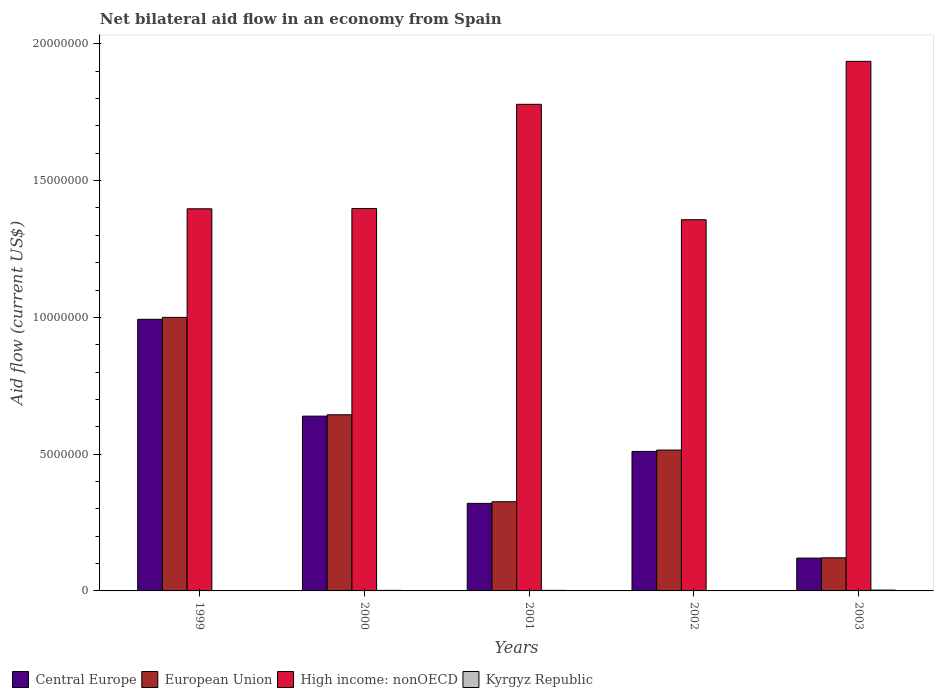Are the number of bars per tick equal to the number of legend labels?
Offer a terse response. Yes. Are the number of bars on each tick of the X-axis equal?
Your answer should be compact. Yes. How many bars are there on the 1st tick from the left?
Ensure brevity in your answer.  4. What is the label of the 5th group of bars from the left?
Your answer should be compact. 2003. In how many cases, is the number of bars for a given year not equal to the number of legend labels?
Give a very brief answer. 0. What is the net bilateral aid flow in Central Europe in 2002?
Ensure brevity in your answer.  5.10e+06. Across all years, what is the minimum net bilateral aid flow in Central Europe?
Ensure brevity in your answer.  1.20e+06. In which year was the net bilateral aid flow in European Union maximum?
Give a very brief answer. 1999. What is the total net bilateral aid flow in European Union in the graph?
Your answer should be compact. 2.61e+07. What is the difference between the net bilateral aid flow in Kyrgyz Republic in 2001 and that in 2003?
Your answer should be compact. -10000. What is the difference between the net bilateral aid flow in Kyrgyz Republic in 2000 and the net bilateral aid flow in High income: nonOECD in 2002?
Ensure brevity in your answer.  -1.36e+07. What is the average net bilateral aid flow in Kyrgyz Republic per year?
Provide a succinct answer. 1.80e+04. In how many years, is the net bilateral aid flow in Kyrgyz Republic greater than 16000000 US$?
Your answer should be compact. 0. Is the difference between the net bilateral aid flow in Central Europe in 2000 and 2001 greater than the difference between the net bilateral aid flow in European Union in 2000 and 2001?
Offer a very short reply. Yes. What is the difference between the highest and the second highest net bilateral aid flow in European Union?
Offer a very short reply. 3.56e+06. What is the difference between the highest and the lowest net bilateral aid flow in High income: nonOECD?
Your response must be concise. 5.79e+06. Is the sum of the net bilateral aid flow in High income: nonOECD in 1999 and 2003 greater than the maximum net bilateral aid flow in Kyrgyz Republic across all years?
Your answer should be very brief. Yes. What does the 3rd bar from the left in 2002 represents?
Give a very brief answer. High income: nonOECD. What does the 1st bar from the right in 2002 represents?
Your answer should be very brief. Kyrgyz Republic. Is it the case that in every year, the sum of the net bilateral aid flow in High income: nonOECD and net bilateral aid flow in European Union is greater than the net bilateral aid flow in Central Europe?
Offer a terse response. Yes. How many bars are there?
Offer a terse response. 20. What is the difference between two consecutive major ticks on the Y-axis?
Your answer should be very brief. 5.00e+06. Does the graph contain any zero values?
Your response must be concise. No. How are the legend labels stacked?
Offer a very short reply. Horizontal. What is the title of the graph?
Offer a terse response. Net bilateral aid flow in an economy from Spain. What is the label or title of the X-axis?
Provide a succinct answer. Years. What is the Aid flow (current US$) in Central Europe in 1999?
Your answer should be compact. 9.93e+06. What is the Aid flow (current US$) of European Union in 1999?
Make the answer very short. 1.00e+07. What is the Aid flow (current US$) in High income: nonOECD in 1999?
Your answer should be compact. 1.40e+07. What is the Aid flow (current US$) of Central Europe in 2000?
Provide a short and direct response. 6.39e+06. What is the Aid flow (current US$) in European Union in 2000?
Keep it short and to the point. 6.44e+06. What is the Aid flow (current US$) in High income: nonOECD in 2000?
Your answer should be compact. 1.40e+07. What is the Aid flow (current US$) of Kyrgyz Republic in 2000?
Provide a short and direct response. 2.00e+04. What is the Aid flow (current US$) in Central Europe in 2001?
Your answer should be compact. 3.20e+06. What is the Aid flow (current US$) of European Union in 2001?
Ensure brevity in your answer.  3.26e+06. What is the Aid flow (current US$) of High income: nonOECD in 2001?
Your response must be concise. 1.78e+07. What is the Aid flow (current US$) in Kyrgyz Republic in 2001?
Keep it short and to the point. 2.00e+04. What is the Aid flow (current US$) of Central Europe in 2002?
Make the answer very short. 5.10e+06. What is the Aid flow (current US$) of European Union in 2002?
Your answer should be very brief. 5.15e+06. What is the Aid flow (current US$) in High income: nonOECD in 2002?
Provide a succinct answer. 1.36e+07. What is the Aid flow (current US$) in Central Europe in 2003?
Give a very brief answer. 1.20e+06. What is the Aid flow (current US$) in European Union in 2003?
Provide a short and direct response. 1.21e+06. What is the Aid flow (current US$) in High income: nonOECD in 2003?
Ensure brevity in your answer.  1.94e+07. What is the Aid flow (current US$) in Kyrgyz Republic in 2003?
Provide a succinct answer. 3.00e+04. Across all years, what is the maximum Aid flow (current US$) of Central Europe?
Provide a short and direct response. 9.93e+06. Across all years, what is the maximum Aid flow (current US$) of High income: nonOECD?
Give a very brief answer. 1.94e+07. Across all years, what is the maximum Aid flow (current US$) of Kyrgyz Republic?
Your answer should be compact. 3.00e+04. Across all years, what is the minimum Aid flow (current US$) of Central Europe?
Keep it short and to the point. 1.20e+06. Across all years, what is the minimum Aid flow (current US$) of European Union?
Offer a very short reply. 1.21e+06. Across all years, what is the minimum Aid flow (current US$) of High income: nonOECD?
Offer a terse response. 1.36e+07. What is the total Aid flow (current US$) of Central Europe in the graph?
Keep it short and to the point. 2.58e+07. What is the total Aid flow (current US$) of European Union in the graph?
Your answer should be very brief. 2.61e+07. What is the total Aid flow (current US$) in High income: nonOECD in the graph?
Keep it short and to the point. 7.87e+07. What is the total Aid flow (current US$) in Kyrgyz Republic in the graph?
Provide a succinct answer. 9.00e+04. What is the difference between the Aid flow (current US$) of Central Europe in 1999 and that in 2000?
Your response must be concise. 3.54e+06. What is the difference between the Aid flow (current US$) of European Union in 1999 and that in 2000?
Give a very brief answer. 3.56e+06. What is the difference between the Aid flow (current US$) of High income: nonOECD in 1999 and that in 2000?
Keep it short and to the point. -10000. What is the difference between the Aid flow (current US$) in Kyrgyz Republic in 1999 and that in 2000?
Give a very brief answer. -10000. What is the difference between the Aid flow (current US$) in Central Europe in 1999 and that in 2001?
Provide a short and direct response. 6.73e+06. What is the difference between the Aid flow (current US$) in European Union in 1999 and that in 2001?
Keep it short and to the point. 6.74e+06. What is the difference between the Aid flow (current US$) in High income: nonOECD in 1999 and that in 2001?
Provide a short and direct response. -3.82e+06. What is the difference between the Aid flow (current US$) of Kyrgyz Republic in 1999 and that in 2001?
Keep it short and to the point. -10000. What is the difference between the Aid flow (current US$) in Central Europe in 1999 and that in 2002?
Your response must be concise. 4.83e+06. What is the difference between the Aid flow (current US$) in European Union in 1999 and that in 2002?
Provide a succinct answer. 4.85e+06. What is the difference between the Aid flow (current US$) in Kyrgyz Republic in 1999 and that in 2002?
Give a very brief answer. 0. What is the difference between the Aid flow (current US$) of Central Europe in 1999 and that in 2003?
Offer a very short reply. 8.73e+06. What is the difference between the Aid flow (current US$) in European Union in 1999 and that in 2003?
Your answer should be compact. 8.79e+06. What is the difference between the Aid flow (current US$) of High income: nonOECD in 1999 and that in 2003?
Provide a succinct answer. -5.39e+06. What is the difference between the Aid flow (current US$) of Central Europe in 2000 and that in 2001?
Make the answer very short. 3.19e+06. What is the difference between the Aid flow (current US$) of European Union in 2000 and that in 2001?
Offer a terse response. 3.18e+06. What is the difference between the Aid flow (current US$) in High income: nonOECD in 2000 and that in 2001?
Give a very brief answer. -3.81e+06. What is the difference between the Aid flow (current US$) in Kyrgyz Republic in 2000 and that in 2001?
Provide a short and direct response. 0. What is the difference between the Aid flow (current US$) in Central Europe in 2000 and that in 2002?
Give a very brief answer. 1.29e+06. What is the difference between the Aid flow (current US$) of European Union in 2000 and that in 2002?
Offer a very short reply. 1.29e+06. What is the difference between the Aid flow (current US$) of High income: nonOECD in 2000 and that in 2002?
Your answer should be very brief. 4.10e+05. What is the difference between the Aid flow (current US$) in Central Europe in 2000 and that in 2003?
Provide a succinct answer. 5.19e+06. What is the difference between the Aid flow (current US$) of European Union in 2000 and that in 2003?
Make the answer very short. 5.23e+06. What is the difference between the Aid flow (current US$) in High income: nonOECD in 2000 and that in 2003?
Provide a short and direct response. -5.38e+06. What is the difference between the Aid flow (current US$) of Kyrgyz Republic in 2000 and that in 2003?
Offer a very short reply. -10000. What is the difference between the Aid flow (current US$) of Central Europe in 2001 and that in 2002?
Your answer should be compact. -1.90e+06. What is the difference between the Aid flow (current US$) of European Union in 2001 and that in 2002?
Give a very brief answer. -1.89e+06. What is the difference between the Aid flow (current US$) of High income: nonOECD in 2001 and that in 2002?
Your response must be concise. 4.22e+06. What is the difference between the Aid flow (current US$) in European Union in 2001 and that in 2003?
Your answer should be compact. 2.05e+06. What is the difference between the Aid flow (current US$) of High income: nonOECD in 2001 and that in 2003?
Provide a succinct answer. -1.57e+06. What is the difference between the Aid flow (current US$) of Kyrgyz Republic in 2001 and that in 2003?
Keep it short and to the point. -10000. What is the difference between the Aid flow (current US$) in Central Europe in 2002 and that in 2003?
Your response must be concise. 3.90e+06. What is the difference between the Aid flow (current US$) of European Union in 2002 and that in 2003?
Offer a very short reply. 3.94e+06. What is the difference between the Aid flow (current US$) in High income: nonOECD in 2002 and that in 2003?
Provide a succinct answer. -5.79e+06. What is the difference between the Aid flow (current US$) of Kyrgyz Republic in 2002 and that in 2003?
Provide a succinct answer. -2.00e+04. What is the difference between the Aid flow (current US$) in Central Europe in 1999 and the Aid flow (current US$) in European Union in 2000?
Offer a very short reply. 3.49e+06. What is the difference between the Aid flow (current US$) of Central Europe in 1999 and the Aid flow (current US$) of High income: nonOECD in 2000?
Offer a very short reply. -4.05e+06. What is the difference between the Aid flow (current US$) of Central Europe in 1999 and the Aid flow (current US$) of Kyrgyz Republic in 2000?
Keep it short and to the point. 9.91e+06. What is the difference between the Aid flow (current US$) of European Union in 1999 and the Aid flow (current US$) of High income: nonOECD in 2000?
Your response must be concise. -3.98e+06. What is the difference between the Aid flow (current US$) in European Union in 1999 and the Aid flow (current US$) in Kyrgyz Republic in 2000?
Ensure brevity in your answer.  9.98e+06. What is the difference between the Aid flow (current US$) of High income: nonOECD in 1999 and the Aid flow (current US$) of Kyrgyz Republic in 2000?
Make the answer very short. 1.40e+07. What is the difference between the Aid flow (current US$) in Central Europe in 1999 and the Aid flow (current US$) in European Union in 2001?
Keep it short and to the point. 6.67e+06. What is the difference between the Aid flow (current US$) of Central Europe in 1999 and the Aid flow (current US$) of High income: nonOECD in 2001?
Offer a very short reply. -7.86e+06. What is the difference between the Aid flow (current US$) of Central Europe in 1999 and the Aid flow (current US$) of Kyrgyz Republic in 2001?
Your response must be concise. 9.91e+06. What is the difference between the Aid flow (current US$) in European Union in 1999 and the Aid flow (current US$) in High income: nonOECD in 2001?
Offer a very short reply. -7.79e+06. What is the difference between the Aid flow (current US$) in European Union in 1999 and the Aid flow (current US$) in Kyrgyz Republic in 2001?
Ensure brevity in your answer.  9.98e+06. What is the difference between the Aid flow (current US$) in High income: nonOECD in 1999 and the Aid flow (current US$) in Kyrgyz Republic in 2001?
Your answer should be compact. 1.40e+07. What is the difference between the Aid flow (current US$) in Central Europe in 1999 and the Aid flow (current US$) in European Union in 2002?
Keep it short and to the point. 4.78e+06. What is the difference between the Aid flow (current US$) in Central Europe in 1999 and the Aid flow (current US$) in High income: nonOECD in 2002?
Provide a succinct answer. -3.64e+06. What is the difference between the Aid flow (current US$) of Central Europe in 1999 and the Aid flow (current US$) of Kyrgyz Republic in 2002?
Provide a succinct answer. 9.92e+06. What is the difference between the Aid flow (current US$) of European Union in 1999 and the Aid flow (current US$) of High income: nonOECD in 2002?
Keep it short and to the point. -3.57e+06. What is the difference between the Aid flow (current US$) of European Union in 1999 and the Aid flow (current US$) of Kyrgyz Republic in 2002?
Your answer should be compact. 9.99e+06. What is the difference between the Aid flow (current US$) of High income: nonOECD in 1999 and the Aid flow (current US$) of Kyrgyz Republic in 2002?
Your response must be concise. 1.40e+07. What is the difference between the Aid flow (current US$) in Central Europe in 1999 and the Aid flow (current US$) in European Union in 2003?
Give a very brief answer. 8.72e+06. What is the difference between the Aid flow (current US$) in Central Europe in 1999 and the Aid flow (current US$) in High income: nonOECD in 2003?
Ensure brevity in your answer.  -9.43e+06. What is the difference between the Aid flow (current US$) of Central Europe in 1999 and the Aid flow (current US$) of Kyrgyz Republic in 2003?
Offer a terse response. 9.90e+06. What is the difference between the Aid flow (current US$) in European Union in 1999 and the Aid flow (current US$) in High income: nonOECD in 2003?
Keep it short and to the point. -9.36e+06. What is the difference between the Aid flow (current US$) of European Union in 1999 and the Aid flow (current US$) of Kyrgyz Republic in 2003?
Your answer should be very brief. 9.97e+06. What is the difference between the Aid flow (current US$) of High income: nonOECD in 1999 and the Aid flow (current US$) of Kyrgyz Republic in 2003?
Your answer should be compact. 1.39e+07. What is the difference between the Aid flow (current US$) of Central Europe in 2000 and the Aid flow (current US$) of European Union in 2001?
Your answer should be compact. 3.13e+06. What is the difference between the Aid flow (current US$) in Central Europe in 2000 and the Aid flow (current US$) in High income: nonOECD in 2001?
Your answer should be compact. -1.14e+07. What is the difference between the Aid flow (current US$) of Central Europe in 2000 and the Aid flow (current US$) of Kyrgyz Republic in 2001?
Your answer should be very brief. 6.37e+06. What is the difference between the Aid flow (current US$) in European Union in 2000 and the Aid flow (current US$) in High income: nonOECD in 2001?
Ensure brevity in your answer.  -1.14e+07. What is the difference between the Aid flow (current US$) in European Union in 2000 and the Aid flow (current US$) in Kyrgyz Republic in 2001?
Provide a succinct answer. 6.42e+06. What is the difference between the Aid flow (current US$) in High income: nonOECD in 2000 and the Aid flow (current US$) in Kyrgyz Republic in 2001?
Make the answer very short. 1.40e+07. What is the difference between the Aid flow (current US$) of Central Europe in 2000 and the Aid flow (current US$) of European Union in 2002?
Your answer should be very brief. 1.24e+06. What is the difference between the Aid flow (current US$) of Central Europe in 2000 and the Aid flow (current US$) of High income: nonOECD in 2002?
Offer a terse response. -7.18e+06. What is the difference between the Aid flow (current US$) in Central Europe in 2000 and the Aid flow (current US$) in Kyrgyz Republic in 2002?
Your response must be concise. 6.38e+06. What is the difference between the Aid flow (current US$) of European Union in 2000 and the Aid flow (current US$) of High income: nonOECD in 2002?
Offer a very short reply. -7.13e+06. What is the difference between the Aid flow (current US$) of European Union in 2000 and the Aid flow (current US$) of Kyrgyz Republic in 2002?
Make the answer very short. 6.43e+06. What is the difference between the Aid flow (current US$) in High income: nonOECD in 2000 and the Aid flow (current US$) in Kyrgyz Republic in 2002?
Offer a terse response. 1.40e+07. What is the difference between the Aid flow (current US$) of Central Europe in 2000 and the Aid flow (current US$) of European Union in 2003?
Your answer should be very brief. 5.18e+06. What is the difference between the Aid flow (current US$) in Central Europe in 2000 and the Aid flow (current US$) in High income: nonOECD in 2003?
Provide a short and direct response. -1.30e+07. What is the difference between the Aid flow (current US$) in Central Europe in 2000 and the Aid flow (current US$) in Kyrgyz Republic in 2003?
Your answer should be compact. 6.36e+06. What is the difference between the Aid flow (current US$) of European Union in 2000 and the Aid flow (current US$) of High income: nonOECD in 2003?
Your answer should be very brief. -1.29e+07. What is the difference between the Aid flow (current US$) of European Union in 2000 and the Aid flow (current US$) of Kyrgyz Republic in 2003?
Your answer should be very brief. 6.41e+06. What is the difference between the Aid flow (current US$) of High income: nonOECD in 2000 and the Aid flow (current US$) of Kyrgyz Republic in 2003?
Make the answer very short. 1.40e+07. What is the difference between the Aid flow (current US$) of Central Europe in 2001 and the Aid flow (current US$) of European Union in 2002?
Keep it short and to the point. -1.95e+06. What is the difference between the Aid flow (current US$) of Central Europe in 2001 and the Aid flow (current US$) of High income: nonOECD in 2002?
Give a very brief answer. -1.04e+07. What is the difference between the Aid flow (current US$) in Central Europe in 2001 and the Aid flow (current US$) in Kyrgyz Republic in 2002?
Offer a terse response. 3.19e+06. What is the difference between the Aid flow (current US$) in European Union in 2001 and the Aid flow (current US$) in High income: nonOECD in 2002?
Your answer should be compact. -1.03e+07. What is the difference between the Aid flow (current US$) in European Union in 2001 and the Aid flow (current US$) in Kyrgyz Republic in 2002?
Provide a short and direct response. 3.25e+06. What is the difference between the Aid flow (current US$) of High income: nonOECD in 2001 and the Aid flow (current US$) of Kyrgyz Republic in 2002?
Ensure brevity in your answer.  1.78e+07. What is the difference between the Aid flow (current US$) in Central Europe in 2001 and the Aid flow (current US$) in European Union in 2003?
Your answer should be very brief. 1.99e+06. What is the difference between the Aid flow (current US$) of Central Europe in 2001 and the Aid flow (current US$) of High income: nonOECD in 2003?
Make the answer very short. -1.62e+07. What is the difference between the Aid flow (current US$) of Central Europe in 2001 and the Aid flow (current US$) of Kyrgyz Republic in 2003?
Provide a short and direct response. 3.17e+06. What is the difference between the Aid flow (current US$) of European Union in 2001 and the Aid flow (current US$) of High income: nonOECD in 2003?
Your response must be concise. -1.61e+07. What is the difference between the Aid flow (current US$) in European Union in 2001 and the Aid flow (current US$) in Kyrgyz Republic in 2003?
Keep it short and to the point. 3.23e+06. What is the difference between the Aid flow (current US$) in High income: nonOECD in 2001 and the Aid flow (current US$) in Kyrgyz Republic in 2003?
Your response must be concise. 1.78e+07. What is the difference between the Aid flow (current US$) of Central Europe in 2002 and the Aid flow (current US$) of European Union in 2003?
Ensure brevity in your answer.  3.89e+06. What is the difference between the Aid flow (current US$) of Central Europe in 2002 and the Aid flow (current US$) of High income: nonOECD in 2003?
Make the answer very short. -1.43e+07. What is the difference between the Aid flow (current US$) of Central Europe in 2002 and the Aid flow (current US$) of Kyrgyz Republic in 2003?
Your answer should be very brief. 5.07e+06. What is the difference between the Aid flow (current US$) of European Union in 2002 and the Aid flow (current US$) of High income: nonOECD in 2003?
Offer a terse response. -1.42e+07. What is the difference between the Aid flow (current US$) of European Union in 2002 and the Aid flow (current US$) of Kyrgyz Republic in 2003?
Give a very brief answer. 5.12e+06. What is the difference between the Aid flow (current US$) in High income: nonOECD in 2002 and the Aid flow (current US$) in Kyrgyz Republic in 2003?
Your answer should be compact. 1.35e+07. What is the average Aid flow (current US$) of Central Europe per year?
Offer a very short reply. 5.16e+06. What is the average Aid flow (current US$) in European Union per year?
Your answer should be very brief. 5.21e+06. What is the average Aid flow (current US$) of High income: nonOECD per year?
Offer a very short reply. 1.57e+07. What is the average Aid flow (current US$) of Kyrgyz Republic per year?
Keep it short and to the point. 1.80e+04. In the year 1999, what is the difference between the Aid flow (current US$) in Central Europe and Aid flow (current US$) in European Union?
Provide a succinct answer. -7.00e+04. In the year 1999, what is the difference between the Aid flow (current US$) of Central Europe and Aid flow (current US$) of High income: nonOECD?
Provide a short and direct response. -4.04e+06. In the year 1999, what is the difference between the Aid flow (current US$) of Central Europe and Aid flow (current US$) of Kyrgyz Republic?
Your response must be concise. 9.92e+06. In the year 1999, what is the difference between the Aid flow (current US$) in European Union and Aid flow (current US$) in High income: nonOECD?
Keep it short and to the point. -3.97e+06. In the year 1999, what is the difference between the Aid flow (current US$) of European Union and Aid flow (current US$) of Kyrgyz Republic?
Your response must be concise. 9.99e+06. In the year 1999, what is the difference between the Aid flow (current US$) in High income: nonOECD and Aid flow (current US$) in Kyrgyz Republic?
Your response must be concise. 1.40e+07. In the year 2000, what is the difference between the Aid flow (current US$) of Central Europe and Aid flow (current US$) of High income: nonOECD?
Offer a very short reply. -7.59e+06. In the year 2000, what is the difference between the Aid flow (current US$) of Central Europe and Aid flow (current US$) of Kyrgyz Republic?
Your response must be concise. 6.37e+06. In the year 2000, what is the difference between the Aid flow (current US$) of European Union and Aid flow (current US$) of High income: nonOECD?
Provide a succinct answer. -7.54e+06. In the year 2000, what is the difference between the Aid flow (current US$) of European Union and Aid flow (current US$) of Kyrgyz Republic?
Your answer should be very brief. 6.42e+06. In the year 2000, what is the difference between the Aid flow (current US$) of High income: nonOECD and Aid flow (current US$) of Kyrgyz Republic?
Give a very brief answer. 1.40e+07. In the year 2001, what is the difference between the Aid flow (current US$) in Central Europe and Aid flow (current US$) in European Union?
Offer a terse response. -6.00e+04. In the year 2001, what is the difference between the Aid flow (current US$) in Central Europe and Aid flow (current US$) in High income: nonOECD?
Provide a short and direct response. -1.46e+07. In the year 2001, what is the difference between the Aid flow (current US$) of Central Europe and Aid flow (current US$) of Kyrgyz Republic?
Your answer should be compact. 3.18e+06. In the year 2001, what is the difference between the Aid flow (current US$) in European Union and Aid flow (current US$) in High income: nonOECD?
Provide a short and direct response. -1.45e+07. In the year 2001, what is the difference between the Aid flow (current US$) of European Union and Aid flow (current US$) of Kyrgyz Republic?
Offer a very short reply. 3.24e+06. In the year 2001, what is the difference between the Aid flow (current US$) of High income: nonOECD and Aid flow (current US$) of Kyrgyz Republic?
Provide a short and direct response. 1.78e+07. In the year 2002, what is the difference between the Aid flow (current US$) in Central Europe and Aid flow (current US$) in High income: nonOECD?
Provide a short and direct response. -8.47e+06. In the year 2002, what is the difference between the Aid flow (current US$) in Central Europe and Aid flow (current US$) in Kyrgyz Republic?
Your response must be concise. 5.09e+06. In the year 2002, what is the difference between the Aid flow (current US$) in European Union and Aid flow (current US$) in High income: nonOECD?
Make the answer very short. -8.42e+06. In the year 2002, what is the difference between the Aid flow (current US$) of European Union and Aid flow (current US$) of Kyrgyz Republic?
Ensure brevity in your answer.  5.14e+06. In the year 2002, what is the difference between the Aid flow (current US$) in High income: nonOECD and Aid flow (current US$) in Kyrgyz Republic?
Make the answer very short. 1.36e+07. In the year 2003, what is the difference between the Aid flow (current US$) in Central Europe and Aid flow (current US$) in High income: nonOECD?
Ensure brevity in your answer.  -1.82e+07. In the year 2003, what is the difference between the Aid flow (current US$) in Central Europe and Aid flow (current US$) in Kyrgyz Republic?
Provide a short and direct response. 1.17e+06. In the year 2003, what is the difference between the Aid flow (current US$) of European Union and Aid flow (current US$) of High income: nonOECD?
Keep it short and to the point. -1.82e+07. In the year 2003, what is the difference between the Aid flow (current US$) in European Union and Aid flow (current US$) in Kyrgyz Republic?
Your response must be concise. 1.18e+06. In the year 2003, what is the difference between the Aid flow (current US$) in High income: nonOECD and Aid flow (current US$) in Kyrgyz Republic?
Give a very brief answer. 1.93e+07. What is the ratio of the Aid flow (current US$) in Central Europe in 1999 to that in 2000?
Your response must be concise. 1.55. What is the ratio of the Aid flow (current US$) of European Union in 1999 to that in 2000?
Give a very brief answer. 1.55. What is the ratio of the Aid flow (current US$) in Kyrgyz Republic in 1999 to that in 2000?
Keep it short and to the point. 0.5. What is the ratio of the Aid flow (current US$) of Central Europe in 1999 to that in 2001?
Keep it short and to the point. 3.1. What is the ratio of the Aid flow (current US$) in European Union in 1999 to that in 2001?
Ensure brevity in your answer.  3.07. What is the ratio of the Aid flow (current US$) in High income: nonOECD in 1999 to that in 2001?
Provide a short and direct response. 0.79. What is the ratio of the Aid flow (current US$) of Kyrgyz Republic in 1999 to that in 2001?
Offer a very short reply. 0.5. What is the ratio of the Aid flow (current US$) in Central Europe in 1999 to that in 2002?
Your answer should be compact. 1.95. What is the ratio of the Aid flow (current US$) of European Union in 1999 to that in 2002?
Ensure brevity in your answer.  1.94. What is the ratio of the Aid flow (current US$) in High income: nonOECD in 1999 to that in 2002?
Offer a very short reply. 1.03. What is the ratio of the Aid flow (current US$) of Central Europe in 1999 to that in 2003?
Your answer should be compact. 8.28. What is the ratio of the Aid flow (current US$) in European Union in 1999 to that in 2003?
Give a very brief answer. 8.26. What is the ratio of the Aid flow (current US$) of High income: nonOECD in 1999 to that in 2003?
Your response must be concise. 0.72. What is the ratio of the Aid flow (current US$) in Central Europe in 2000 to that in 2001?
Provide a short and direct response. 2. What is the ratio of the Aid flow (current US$) of European Union in 2000 to that in 2001?
Keep it short and to the point. 1.98. What is the ratio of the Aid flow (current US$) of High income: nonOECD in 2000 to that in 2001?
Provide a short and direct response. 0.79. What is the ratio of the Aid flow (current US$) of Central Europe in 2000 to that in 2002?
Provide a short and direct response. 1.25. What is the ratio of the Aid flow (current US$) of European Union in 2000 to that in 2002?
Give a very brief answer. 1.25. What is the ratio of the Aid flow (current US$) of High income: nonOECD in 2000 to that in 2002?
Keep it short and to the point. 1.03. What is the ratio of the Aid flow (current US$) of Central Europe in 2000 to that in 2003?
Offer a terse response. 5.33. What is the ratio of the Aid flow (current US$) in European Union in 2000 to that in 2003?
Give a very brief answer. 5.32. What is the ratio of the Aid flow (current US$) of High income: nonOECD in 2000 to that in 2003?
Offer a very short reply. 0.72. What is the ratio of the Aid flow (current US$) in Central Europe in 2001 to that in 2002?
Provide a short and direct response. 0.63. What is the ratio of the Aid flow (current US$) in European Union in 2001 to that in 2002?
Ensure brevity in your answer.  0.63. What is the ratio of the Aid flow (current US$) in High income: nonOECD in 2001 to that in 2002?
Provide a short and direct response. 1.31. What is the ratio of the Aid flow (current US$) in Central Europe in 2001 to that in 2003?
Your answer should be very brief. 2.67. What is the ratio of the Aid flow (current US$) in European Union in 2001 to that in 2003?
Offer a very short reply. 2.69. What is the ratio of the Aid flow (current US$) of High income: nonOECD in 2001 to that in 2003?
Ensure brevity in your answer.  0.92. What is the ratio of the Aid flow (current US$) of Kyrgyz Republic in 2001 to that in 2003?
Make the answer very short. 0.67. What is the ratio of the Aid flow (current US$) in Central Europe in 2002 to that in 2003?
Offer a very short reply. 4.25. What is the ratio of the Aid flow (current US$) of European Union in 2002 to that in 2003?
Offer a very short reply. 4.26. What is the ratio of the Aid flow (current US$) of High income: nonOECD in 2002 to that in 2003?
Keep it short and to the point. 0.7. What is the difference between the highest and the second highest Aid flow (current US$) of Central Europe?
Your response must be concise. 3.54e+06. What is the difference between the highest and the second highest Aid flow (current US$) of European Union?
Offer a very short reply. 3.56e+06. What is the difference between the highest and the second highest Aid flow (current US$) in High income: nonOECD?
Offer a very short reply. 1.57e+06. What is the difference between the highest and the lowest Aid flow (current US$) in Central Europe?
Your answer should be very brief. 8.73e+06. What is the difference between the highest and the lowest Aid flow (current US$) of European Union?
Offer a very short reply. 8.79e+06. What is the difference between the highest and the lowest Aid flow (current US$) in High income: nonOECD?
Give a very brief answer. 5.79e+06. 